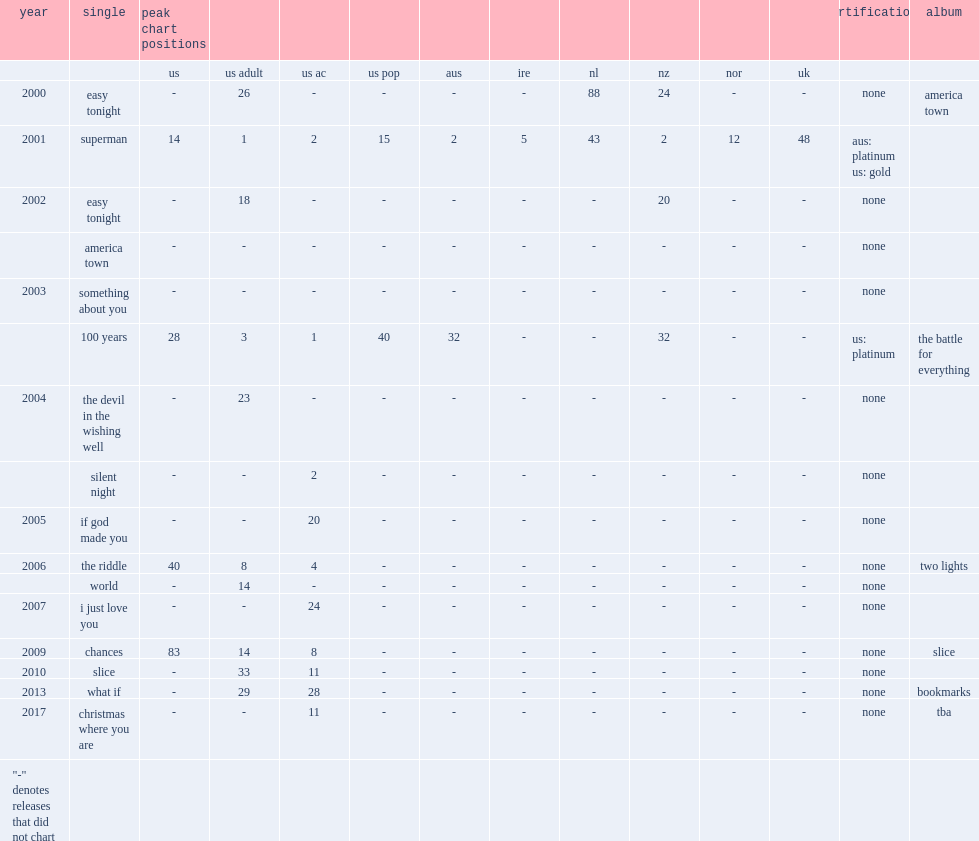When did the album slice release? 2010.0. 